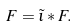Convert formula to latex. <formula><loc_0><loc_0><loc_500><loc_500>F = \tilde { \iota } \ast F .</formula> 